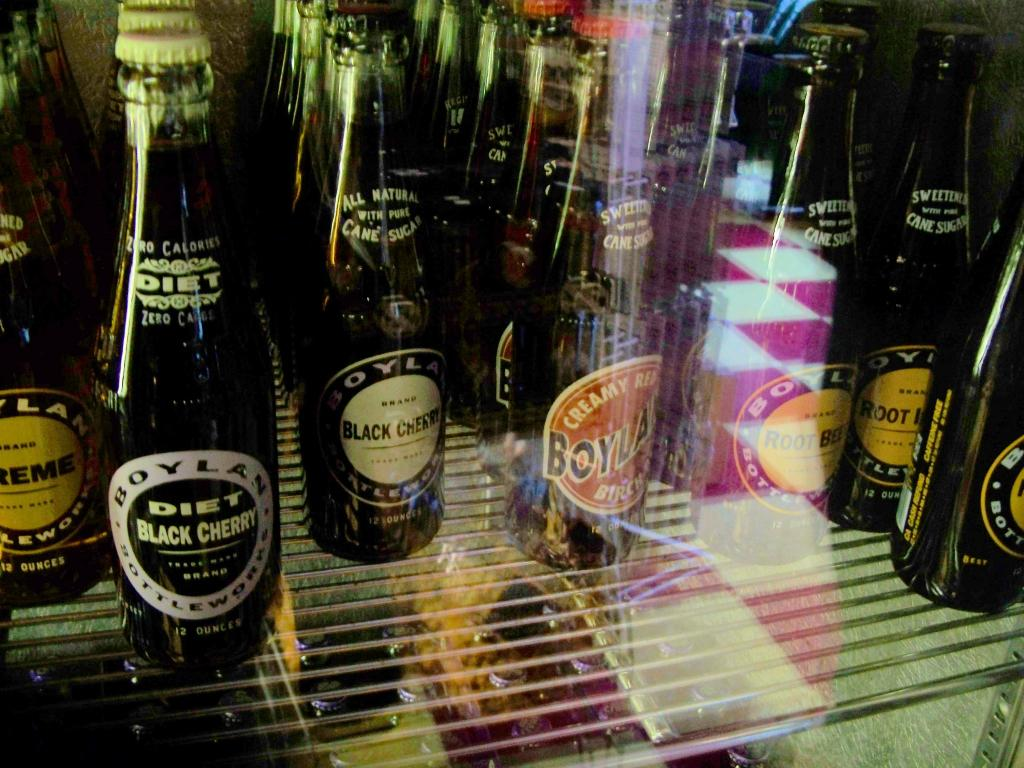What is the main subject of the image? The main subject of the image is a group of beer bottles. How are the bottles arranged in the image? The bottles are placed in an order in the image. What type of closure is used on the bottles? The bottles are sealed with a metal cap. Where are the bottles placed in the image? The bottles are placed in a rack in the image. What type of spring can be seen in the image? There is no spring present in the image. What type of vessel is used to hold the beer bottles in the image? The image does not show a vessel holding the beer bottles; they are placed in a rack. 